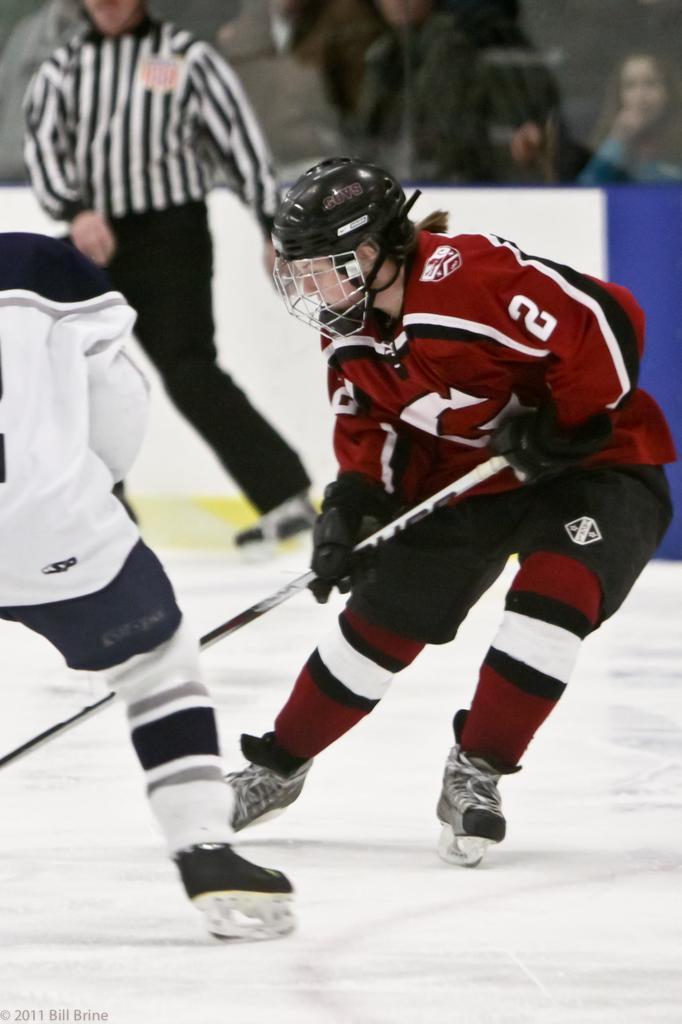How would you summarize this image in a sentence or two? In this picture we can see two persons are playing ice hockey, a person on the right side is wearing a helmet and holding a stick, we can also see some people in the background. 